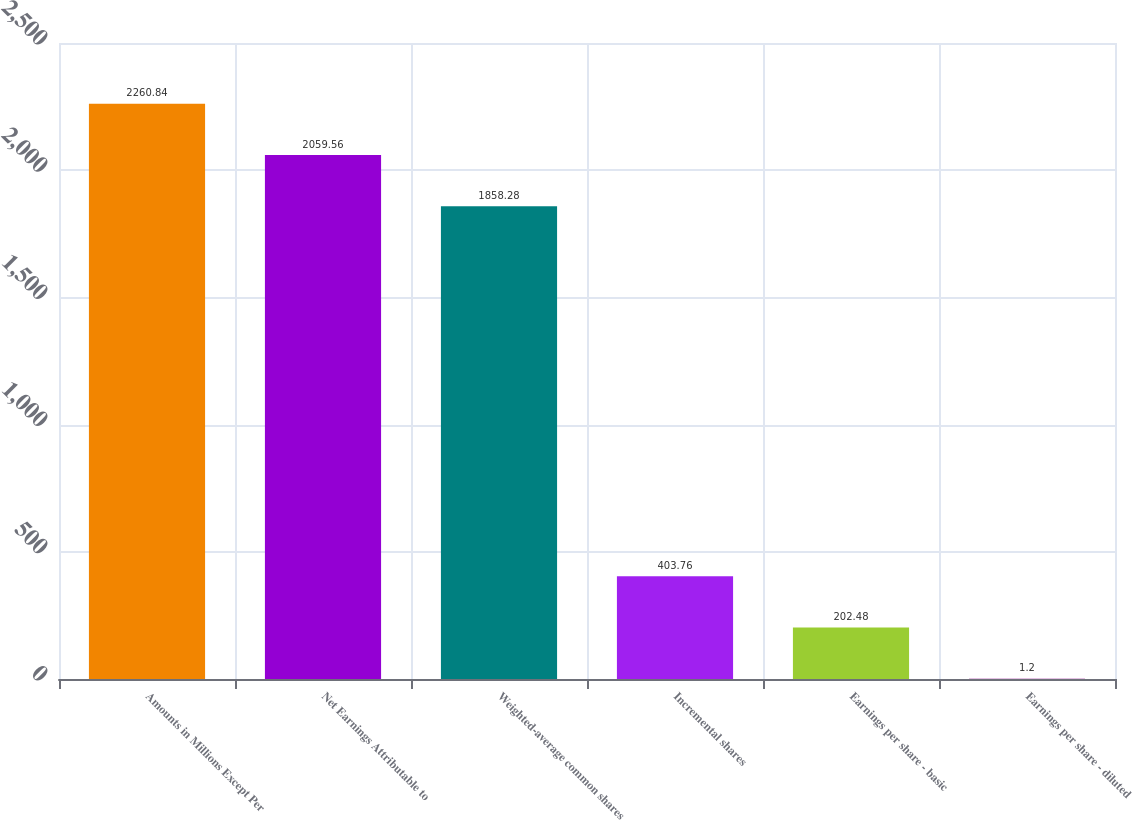Convert chart to OTSL. <chart><loc_0><loc_0><loc_500><loc_500><bar_chart><fcel>Amounts in Millions Except Per<fcel>Net Earnings Attributable to<fcel>Weighted-average common shares<fcel>Incremental shares<fcel>Earnings per share - basic<fcel>Earnings per share - diluted<nl><fcel>2260.84<fcel>2059.56<fcel>1858.28<fcel>403.76<fcel>202.48<fcel>1.2<nl></chart> 